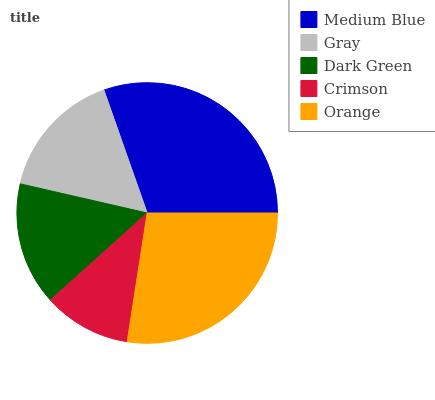Is Crimson the minimum?
Answer yes or no. Yes. Is Medium Blue the maximum?
Answer yes or no. Yes. Is Gray the minimum?
Answer yes or no. No. Is Gray the maximum?
Answer yes or no. No. Is Medium Blue greater than Gray?
Answer yes or no. Yes. Is Gray less than Medium Blue?
Answer yes or no. Yes. Is Gray greater than Medium Blue?
Answer yes or no. No. Is Medium Blue less than Gray?
Answer yes or no. No. Is Gray the high median?
Answer yes or no. Yes. Is Gray the low median?
Answer yes or no. Yes. Is Dark Green the high median?
Answer yes or no. No. Is Medium Blue the low median?
Answer yes or no. No. 